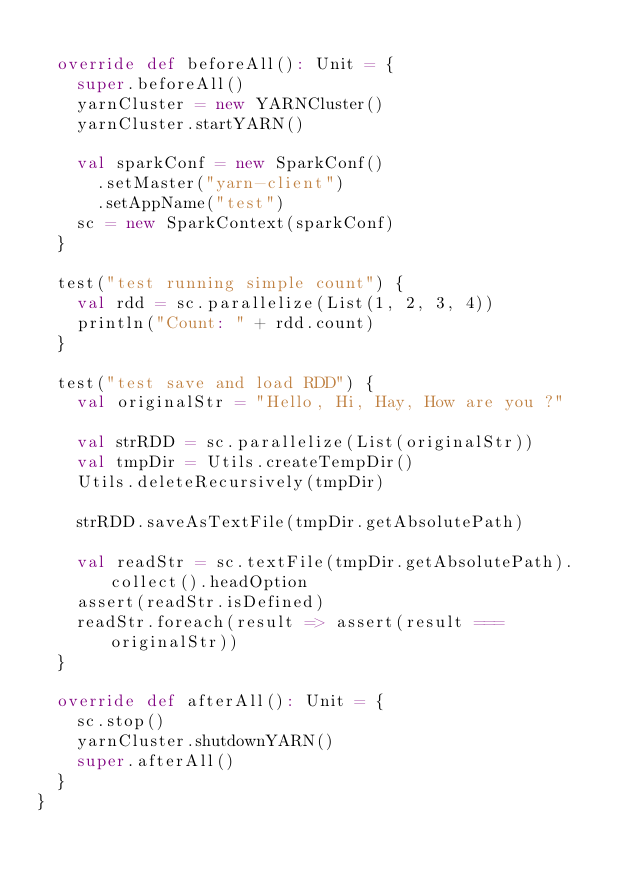<code> <loc_0><loc_0><loc_500><loc_500><_Scala_>
  override def beforeAll(): Unit = {
    super.beforeAll()
    yarnCluster = new YARNCluster()
    yarnCluster.startYARN()

    val sparkConf = new SparkConf()
      .setMaster("yarn-client")
      .setAppName("test")
    sc = new SparkContext(sparkConf)
  }

  test("test running simple count") {
    val rdd = sc.parallelize(List(1, 2, 3, 4))
    println("Count: " + rdd.count)
  }

  test("test save and load RDD") {
    val originalStr = "Hello, Hi, Hay, How are you ?"

    val strRDD = sc.parallelize(List(originalStr))
    val tmpDir = Utils.createTempDir()
    Utils.deleteRecursively(tmpDir)

    strRDD.saveAsTextFile(tmpDir.getAbsolutePath)

    val readStr = sc.textFile(tmpDir.getAbsolutePath).collect().headOption
    assert(readStr.isDefined)
    readStr.foreach(result => assert(result === originalStr))
  }

  override def afterAll(): Unit = {
    sc.stop()
    yarnCluster.shutdownYARN()
    super.afterAll()
  }
}
</code> 